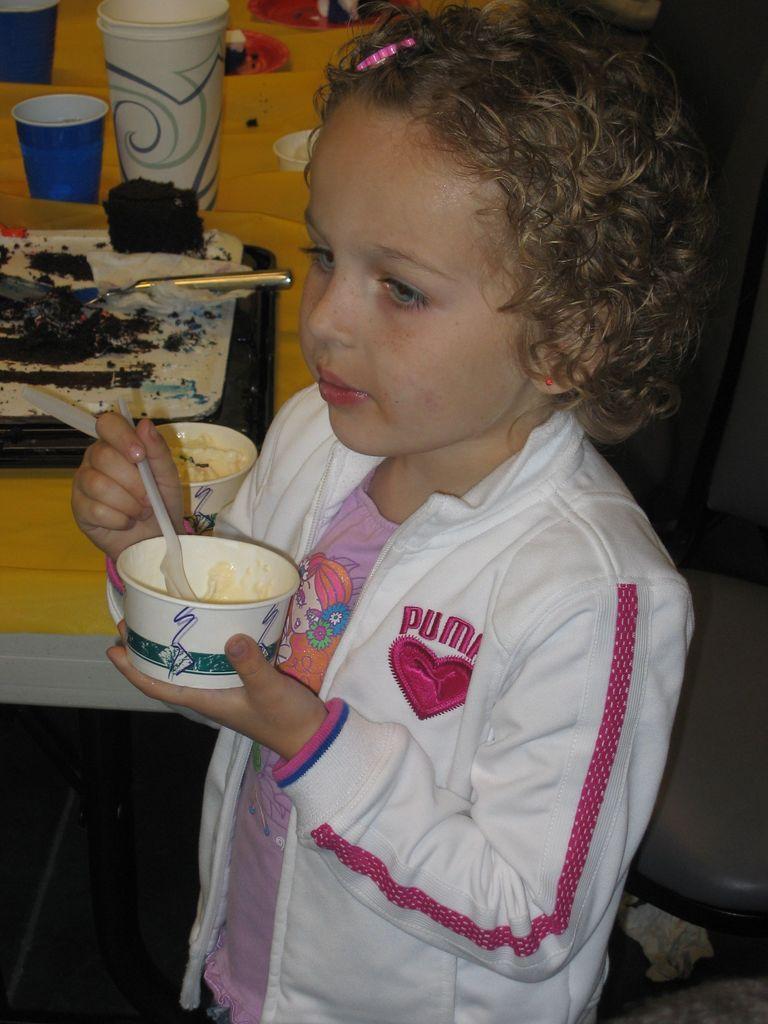How would you summarize this image in a sentence or two? In the foreground of this picture we can see a kid wearing white color jacket, holding a bowl of food and spoon and standing and we can see a table on the top of which cake, glasses and some other objects are placed and we can see the chairs and some other objects in the background. 